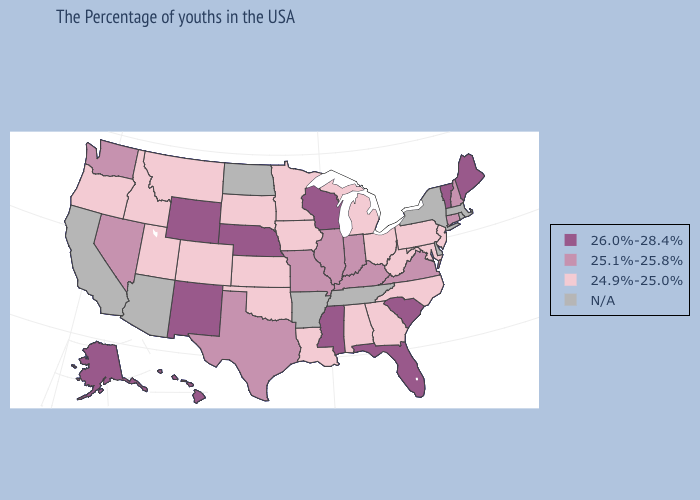Does the map have missing data?
Quick response, please. Yes. What is the lowest value in the South?
Quick response, please. 24.9%-25.0%. Name the states that have a value in the range N/A?
Quick response, please. Massachusetts, Rhode Island, New York, Delaware, Tennessee, Arkansas, North Dakota, Arizona, California. What is the highest value in the West ?
Be succinct. 26.0%-28.4%. What is the highest value in the South ?
Be succinct. 26.0%-28.4%. Which states have the lowest value in the MidWest?
Write a very short answer. Ohio, Michigan, Minnesota, Iowa, Kansas, South Dakota. Name the states that have a value in the range N/A?
Answer briefly. Massachusetts, Rhode Island, New York, Delaware, Tennessee, Arkansas, North Dakota, Arizona, California. Name the states that have a value in the range 26.0%-28.4%?
Answer briefly. Maine, Vermont, South Carolina, Florida, Wisconsin, Mississippi, Nebraska, Wyoming, New Mexico, Alaska, Hawaii. Among the states that border California , does Oregon have the lowest value?
Short answer required. Yes. Which states hav the highest value in the West?
Short answer required. Wyoming, New Mexico, Alaska, Hawaii. Among the states that border Rhode Island , which have the lowest value?
Be succinct. Connecticut. What is the value of Rhode Island?
Quick response, please. N/A. What is the value of Maryland?
Concise answer only. 24.9%-25.0%. 